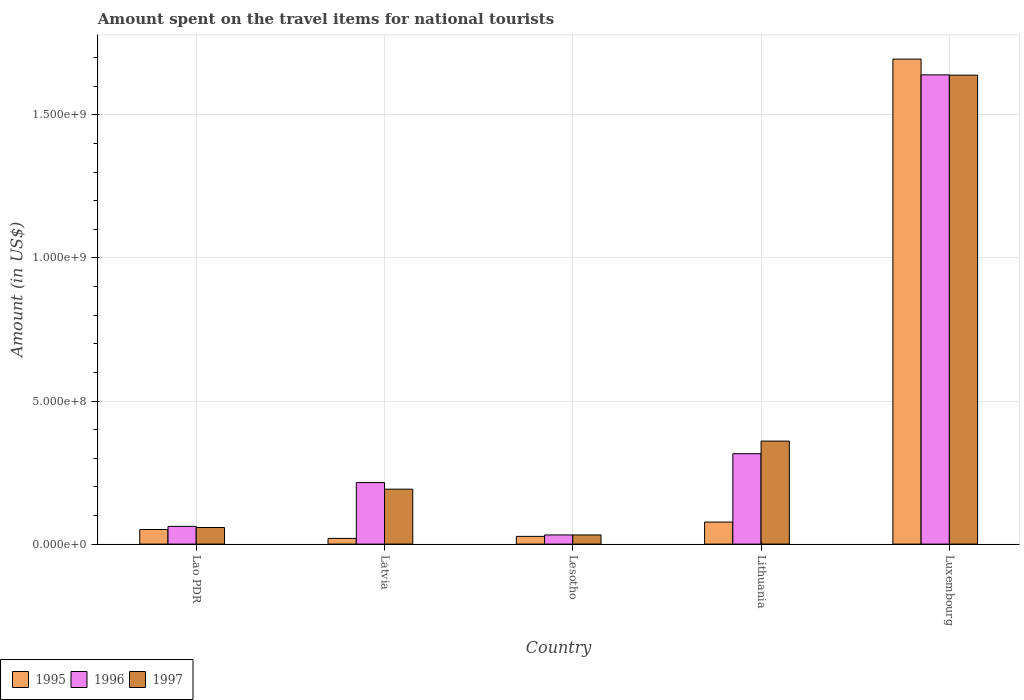Are the number of bars per tick equal to the number of legend labels?
Offer a terse response. Yes. Are the number of bars on each tick of the X-axis equal?
Make the answer very short. Yes. How many bars are there on the 1st tick from the left?
Your response must be concise. 3. How many bars are there on the 3rd tick from the right?
Make the answer very short. 3. What is the label of the 3rd group of bars from the left?
Give a very brief answer. Lesotho. In how many cases, is the number of bars for a given country not equal to the number of legend labels?
Offer a very short reply. 0. What is the amount spent on the travel items for national tourists in 1995 in Lao PDR?
Give a very brief answer. 5.10e+07. Across all countries, what is the maximum amount spent on the travel items for national tourists in 1996?
Give a very brief answer. 1.64e+09. Across all countries, what is the minimum amount spent on the travel items for national tourists in 1996?
Your response must be concise. 3.20e+07. In which country was the amount spent on the travel items for national tourists in 1996 maximum?
Offer a very short reply. Luxembourg. In which country was the amount spent on the travel items for national tourists in 1995 minimum?
Offer a very short reply. Latvia. What is the total amount spent on the travel items for national tourists in 1996 in the graph?
Offer a terse response. 2.26e+09. What is the difference between the amount spent on the travel items for national tourists in 1997 in Lao PDR and that in Lithuania?
Provide a succinct answer. -3.02e+08. What is the difference between the amount spent on the travel items for national tourists in 1995 in Luxembourg and the amount spent on the travel items for national tourists in 1997 in Lithuania?
Make the answer very short. 1.34e+09. What is the average amount spent on the travel items for national tourists in 1997 per country?
Your answer should be very brief. 4.56e+08. What is the difference between the amount spent on the travel items for national tourists of/in 1997 and amount spent on the travel items for national tourists of/in 1996 in Luxembourg?
Your answer should be very brief. -1.00e+06. In how many countries, is the amount spent on the travel items for national tourists in 1996 greater than 300000000 US$?
Provide a short and direct response. 2. What is the ratio of the amount spent on the travel items for national tourists in 1997 in Lesotho to that in Luxembourg?
Your answer should be compact. 0.02. Is the amount spent on the travel items for national tourists in 1996 in Latvia less than that in Luxembourg?
Give a very brief answer. Yes. Is the difference between the amount spent on the travel items for national tourists in 1997 in Lesotho and Lithuania greater than the difference between the amount spent on the travel items for national tourists in 1996 in Lesotho and Lithuania?
Give a very brief answer. No. What is the difference between the highest and the second highest amount spent on the travel items for national tourists in 1997?
Provide a succinct answer. 1.28e+09. What is the difference between the highest and the lowest amount spent on the travel items for national tourists in 1996?
Offer a very short reply. 1.61e+09. What does the 2nd bar from the left in Latvia represents?
Provide a short and direct response. 1996. What does the 3rd bar from the right in Latvia represents?
Your answer should be very brief. 1995. Is it the case that in every country, the sum of the amount spent on the travel items for national tourists in 1997 and amount spent on the travel items for national tourists in 1995 is greater than the amount spent on the travel items for national tourists in 1996?
Offer a very short reply. No. How many bars are there?
Offer a terse response. 15. Are all the bars in the graph horizontal?
Offer a terse response. No. What is the difference between two consecutive major ticks on the Y-axis?
Make the answer very short. 5.00e+08. Where does the legend appear in the graph?
Provide a succinct answer. Bottom left. How are the legend labels stacked?
Make the answer very short. Horizontal. What is the title of the graph?
Keep it short and to the point. Amount spent on the travel items for national tourists. What is the label or title of the Y-axis?
Keep it short and to the point. Amount (in US$). What is the Amount (in US$) of 1995 in Lao PDR?
Keep it short and to the point. 5.10e+07. What is the Amount (in US$) of 1996 in Lao PDR?
Your answer should be very brief. 6.20e+07. What is the Amount (in US$) of 1997 in Lao PDR?
Provide a short and direct response. 5.80e+07. What is the Amount (in US$) in 1996 in Latvia?
Your answer should be compact. 2.15e+08. What is the Amount (in US$) in 1997 in Latvia?
Offer a terse response. 1.92e+08. What is the Amount (in US$) of 1995 in Lesotho?
Keep it short and to the point. 2.70e+07. What is the Amount (in US$) of 1996 in Lesotho?
Give a very brief answer. 3.20e+07. What is the Amount (in US$) in 1997 in Lesotho?
Your answer should be compact. 3.20e+07. What is the Amount (in US$) of 1995 in Lithuania?
Offer a terse response. 7.70e+07. What is the Amount (in US$) of 1996 in Lithuania?
Make the answer very short. 3.16e+08. What is the Amount (in US$) in 1997 in Lithuania?
Your response must be concise. 3.60e+08. What is the Amount (in US$) of 1995 in Luxembourg?
Your answer should be compact. 1.70e+09. What is the Amount (in US$) in 1996 in Luxembourg?
Make the answer very short. 1.64e+09. What is the Amount (in US$) in 1997 in Luxembourg?
Your answer should be compact. 1.64e+09. Across all countries, what is the maximum Amount (in US$) in 1995?
Your response must be concise. 1.70e+09. Across all countries, what is the maximum Amount (in US$) in 1996?
Provide a succinct answer. 1.64e+09. Across all countries, what is the maximum Amount (in US$) in 1997?
Your answer should be compact. 1.64e+09. Across all countries, what is the minimum Amount (in US$) in 1995?
Your answer should be compact. 2.00e+07. Across all countries, what is the minimum Amount (in US$) of 1996?
Offer a terse response. 3.20e+07. Across all countries, what is the minimum Amount (in US$) of 1997?
Your answer should be compact. 3.20e+07. What is the total Amount (in US$) of 1995 in the graph?
Make the answer very short. 1.87e+09. What is the total Amount (in US$) of 1996 in the graph?
Your answer should be compact. 2.26e+09. What is the total Amount (in US$) of 1997 in the graph?
Provide a short and direct response. 2.28e+09. What is the difference between the Amount (in US$) of 1995 in Lao PDR and that in Latvia?
Provide a succinct answer. 3.10e+07. What is the difference between the Amount (in US$) of 1996 in Lao PDR and that in Latvia?
Offer a very short reply. -1.53e+08. What is the difference between the Amount (in US$) of 1997 in Lao PDR and that in Latvia?
Keep it short and to the point. -1.34e+08. What is the difference between the Amount (in US$) in 1995 in Lao PDR and that in Lesotho?
Provide a short and direct response. 2.40e+07. What is the difference between the Amount (in US$) in 1996 in Lao PDR and that in Lesotho?
Ensure brevity in your answer.  3.00e+07. What is the difference between the Amount (in US$) in 1997 in Lao PDR and that in Lesotho?
Give a very brief answer. 2.60e+07. What is the difference between the Amount (in US$) in 1995 in Lao PDR and that in Lithuania?
Give a very brief answer. -2.60e+07. What is the difference between the Amount (in US$) of 1996 in Lao PDR and that in Lithuania?
Offer a terse response. -2.54e+08. What is the difference between the Amount (in US$) of 1997 in Lao PDR and that in Lithuania?
Your response must be concise. -3.02e+08. What is the difference between the Amount (in US$) in 1995 in Lao PDR and that in Luxembourg?
Provide a succinct answer. -1.64e+09. What is the difference between the Amount (in US$) in 1996 in Lao PDR and that in Luxembourg?
Give a very brief answer. -1.58e+09. What is the difference between the Amount (in US$) of 1997 in Lao PDR and that in Luxembourg?
Offer a very short reply. -1.58e+09. What is the difference between the Amount (in US$) of 1995 in Latvia and that in Lesotho?
Provide a succinct answer. -7.00e+06. What is the difference between the Amount (in US$) of 1996 in Latvia and that in Lesotho?
Provide a short and direct response. 1.83e+08. What is the difference between the Amount (in US$) of 1997 in Latvia and that in Lesotho?
Offer a very short reply. 1.60e+08. What is the difference between the Amount (in US$) of 1995 in Latvia and that in Lithuania?
Offer a terse response. -5.70e+07. What is the difference between the Amount (in US$) of 1996 in Latvia and that in Lithuania?
Provide a succinct answer. -1.01e+08. What is the difference between the Amount (in US$) of 1997 in Latvia and that in Lithuania?
Your answer should be compact. -1.68e+08. What is the difference between the Amount (in US$) of 1995 in Latvia and that in Luxembourg?
Give a very brief answer. -1.68e+09. What is the difference between the Amount (in US$) of 1996 in Latvia and that in Luxembourg?
Your answer should be compact. -1.42e+09. What is the difference between the Amount (in US$) of 1997 in Latvia and that in Luxembourg?
Provide a succinct answer. -1.45e+09. What is the difference between the Amount (in US$) of 1995 in Lesotho and that in Lithuania?
Provide a succinct answer. -5.00e+07. What is the difference between the Amount (in US$) in 1996 in Lesotho and that in Lithuania?
Ensure brevity in your answer.  -2.84e+08. What is the difference between the Amount (in US$) of 1997 in Lesotho and that in Lithuania?
Your answer should be very brief. -3.28e+08. What is the difference between the Amount (in US$) of 1995 in Lesotho and that in Luxembourg?
Ensure brevity in your answer.  -1.67e+09. What is the difference between the Amount (in US$) in 1996 in Lesotho and that in Luxembourg?
Make the answer very short. -1.61e+09. What is the difference between the Amount (in US$) in 1997 in Lesotho and that in Luxembourg?
Offer a terse response. -1.61e+09. What is the difference between the Amount (in US$) of 1995 in Lithuania and that in Luxembourg?
Give a very brief answer. -1.62e+09. What is the difference between the Amount (in US$) of 1996 in Lithuania and that in Luxembourg?
Keep it short and to the point. -1.32e+09. What is the difference between the Amount (in US$) of 1997 in Lithuania and that in Luxembourg?
Offer a very short reply. -1.28e+09. What is the difference between the Amount (in US$) in 1995 in Lao PDR and the Amount (in US$) in 1996 in Latvia?
Provide a short and direct response. -1.64e+08. What is the difference between the Amount (in US$) in 1995 in Lao PDR and the Amount (in US$) in 1997 in Latvia?
Provide a succinct answer. -1.41e+08. What is the difference between the Amount (in US$) in 1996 in Lao PDR and the Amount (in US$) in 1997 in Latvia?
Make the answer very short. -1.30e+08. What is the difference between the Amount (in US$) in 1995 in Lao PDR and the Amount (in US$) in 1996 in Lesotho?
Offer a terse response. 1.90e+07. What is the difference between the Amount (in US$) of 1995 in Lao PDR and the Amount (in US$) of 1997 in Lesotho?
Your answer should be very brief. 1.90e+07. What is the difference between the Amount (in US$) of 1996 in Lao PDR and the Amount (in US$) of 1997 in Lesotho?
Provide a short and direct response. 3.00e+07. What is the difference between the Amount (in US$) in 1995 in Lao PDR and the Amount (in US$) in 1996 in Lithuania?
Offer a very short reply. -2.65e+08. What is the difference between the Amount (in US$) of 1995 in Lao PDR and the Amount (in US$) of 1997 in Lithuania?
Ensure brevity in your answer.  -3.09e+08. What is the difference between the Amount (in US$) of 1996 in Lao PDR and the Amount (in US$) of 1997 in Lithuania?
Keep it short and to the point. -2.98e+08. What is the difference between the Amount (in US$) of 1995 in Lao PDR and the Amount (in US$) of 1996 in Luxembourg?
Provide a succinct answer. -1.59e+09. What is the difference between the Amount (in US$) of 1995 in Lao PDR and the Amount (in US$) of 1997 in Luxembourg?
Your answer should be compact. -1.59e+09. What is the difference between the Amount (in US$) in 1996 in Lao PDR and the Amount (in US$) in 1997 in Luxembourg?
Your response must be concise. -1.58e+09. What is the difference between the Amount (in US$) of 1995 in Latvia and the Amount (in US$) of 1996 in Lesotho?
Make the answer very short. -1.20e+07. What is the difference between the Amount (in US$) of 1995 in Latvia and the Amount (in US$) of 1997 in Lesotho?
Your answer should be very brief. -1.20e+07. What is the difference between the Amount (in US$) of 1996 in Latvia and the Amount (in US$) of 1997 in Lesotho?
Your answer should be very brief. 1.83e+08. What is the difference between the Amount (in US$) of 1995 in Latvia and the Amount (in US$) of 1996 in Lithuania?
Your answer should be compact. -2.96e+08. What is the difference between the Amount (in US$) in 1995 in Latvia and the Amount (in US$) in 1997 in Lithuania?
Provide a succinct answer. -3.40e+08. What is the difference between the Amount (in US$) of 1996 in Latvia and the Amount (in US$) of 1997 in Lithuania?
Your answer should be compact. -1.45e+08. What is the difference between the Amount (in US$) in 1995 in Latvia and the Amount (in US$) in 1996 in Luxembourg?
Your answer should be very brief. -1.62e+09. What is the difference between the Amount (in US$) of 1995 in Latvia and the Amount (in US$) of 1997 in Luxembourg?
Keep it short and to the point. -1.62e+09. What is the difference between the Amount (in US$) in 1996 in Latvia and the Amount (in US$) in 1997 in Luxembourg?
Offer a very short reply. -1.42e+09. What is the difference between the Amount (in US$) in 1995 in Lesotho and the Amount (in US$) in 1996 in Lithuania?
Offer a terse response. -2.89e+08. What is the difference between the Amount (in US$) in 1995 in Lesotho and the Amount (in US$) in 1997 in Lithuania?
Keep it short and to the point. -3.33e+08. What is the difference between the Amount (in US$) of 1996 in Lesotho and the Amount (in US$) of 1997 in Lithuania?
Your answer should be compact. -3.28e+08. What is the difference between the Amount (in US$) in 1995 in Lesotho and the Amount (in US$) in 1996 in Luxembourg?
Your response must be concise. -1.61e+09. What is the difference between the Amount (in US$) of 1995 in Lesotho and the Amount (in US$) of 1997 in Luxembourg?
Offer a very short reply. -1.61e+09. What is the difference between the Amount (in US$) in 1996 in Lesotho and the Amount (in US$) in 1997 in Luxembourg?
Provide a short and direct response. -1.61e+09. What is the difference between the Amount (in US$) of 1995 in Lithuania and the Amount (in US$) of 1996 in Luxembourg?
Give a very brief answer. -1.56e+09. What is the difference between the Amount (in US$) of 1995 in Lithuania and the Amount (in US$) of 1997 in Luxembourg?
Your answer should be compact. -1.56e+09. What is the difference between the Amount (in US$) of 1996 in Lithuania and the Amount (in US$) of 1997 in Luxembourg?
Give a very brief answer. -1.32e+09. What is the average Amount (in US$) in 1995 per country?
Your answer should be compact. 3.74e+08. What is the average Amount (in US$) in 1996 per country?
Keep it short and to the point. 4.53e+08. What is the average Amount (in US$) of 1997 per country?
Make the answer very short. 4.56e+08. What is the difference between the Amount (in US$) of 1995 and Amount (in US$) of 1996 in Lao PDR?
Your response must be concise. -1.10e+07. What is the difference between the Amount (in US$) in 1995 and Amount (in US$) in 1997 in Lao PDR?
Provide a succinct answer. -7.00e+06. What is the difference between the Amount (in US$) of 1996 and Amount (in US$) of 1997 in Lao PDR?
Give a very brief answer. 4.00e+06. What is the difference between the Amount (in US$) of 1995 and Amount (in US$) of 1996 in Latvia?
Make the answer very short. -1.95e+08. What is the difference between the Amount (in US$) in 1995 and Amount (in US$) in 1997 in Latvia?
Provide a succinct answer. -1.72e+08. What is the difference between the Amount (in US$) in 1996 and Amount (in US$) in 1997 in Latvia?
Provide a succinct answer. 2.30e+07. What is the difference between the Amount (in US$) of 1995 and Amount (in US$) of 1996 in Lesotho?
Your answer should be very brief. -5.00e+06. What is the difference between the Amount (in US$) of 1995 and Amount (in US$) of 1997 in Lesotho?
Your response must be concise. -5.00e+06. What is the difference between the Amount (in US$) of 1995 and Amount (in US$) of 1996 in Lithuania?
Give a very brief answer. -2.39e+08. What is the difference between the Amount (in US$) in 1995 and Amount (in US$) in 1997 in Lithuania?
Give a very brief answer. -2.83e+08. What is the difference between the Amount (in US$) of 1996 and Amount (in US$) of 1997 in Lithuania?
Provide a succinct answer. -4.40e+07. What is the difference between the Amount (in US$) in 1995 and Amount (in US$) in 1996 in Luxembourg?
Your answer should be compact. 5.50e+07. What is the difference between the Amount (in US$) in 1995 and Amount (in US$) in 1997 in Luxembourg?
Provide a succinct answer. 5.60e+07. What is the ratio of the Amount (in US$) of 1995 in Lao PDR to that in Latvia?
Provide a succinct answer. 2.55. What is the ratio of the Amount (in US$) of 1996 in Lao PDR to that in Latvia?
Give a very brief answer. 0.29. What is the ratio of the Amount (in US$) of 1997 in Lao PDR to that in Latvia?
Give a very brief answer. 0.3. What is the ratio of the Amount (in US$) of 1995 in Lao PDR to that in Lesotho?
Give a very brief answer. 1.89. What is the ratio of the Amount (in US$) of 1996 in Lao PDR to that in Lesotho?
Provide a short and direct response. 1.94. What is the ratio of the Amount (in US$) of 1997 in Lao PDR to that in Lesotho?
Keep it short and to the point. 1.81. What is the ratio of the Amount (in US$) of 1995 in Lao PDR to that in Lithuania?
Ensure brevity in your answer.  0.66. What is the ratio of the Amount (in US$) in 1996 in Lao PDR to that in Lithuania?
Offer a terse response. 0.2. What is the ratio of the Amount (in US$) of 1997 in Lao PDR to that in Lithuania?
Provide a succinct answer. 0.16. What is the ratio of the Amount (in US$) of 1995 in Lao PDR to that in Luxembourg?
Provide a short and direct response. 0.03. What is the ratio of the Amount (in US$) of 1996 in Lao PDR to that in Luxembourg?
Offer a terse response. 0.04. What is the ratio of the Amount (in US$) of 1997 in Lao PDR to that in Luxembourg?
Offer a very short reply. 0.04. What is the ratio of the Amount (in US$) in 1995 in Latvia to that in Lesotho?
Offer a terse response. 0.74. What is the ratio of the Amount (in US$) of 1996 in Latvia to that in Lesotho?
Ensure brevity in your answer.  6.72. What is the ratio of the Amount (in US$) in 1995 in Latvia to that in Lithuania?
Offer a terse response. 0.26. What is the ratio of the Amount (in US$) of 1996 in Latvia to that in Lithuania?
Offer a terse response. 0.68. What is the ratio of the Amount (in US$) of 1997 in Latvia to that in Lithuania?
Offer a very short reply. 0.53. What is the ratio of the Amount (in US$) of 1995 in Latvia to that in Luxembourg?
Ensure brevity in your answer.  0.01. What is the ratio of the Amount (in US$) in 1996 in Latvia to that in Luxembourg?
Keep it short and to the point. 0.13. What is the ratio of the Amount (in US$) in 1997 in Latvia to that in Luxembourg?
Your response must be concise. 0.12. What is the ratio of the Amount (in US$) in 1995 in Lesotho to that in Lithuania?
Ensure brevity in your answer.  0.35. What is the ratio of the Amount (in US$) of 1996 in Lesotho to that in Lithuania?
Give a very brief answer. 0.1. What is the ratio of the Amount (in US$) in 1997 in Lesotho to that in Lithuania?
Offer a very short reply. 0.09. What is the ratio of the Amount (in US$) of 1995 in Lesotho to that in Luxembourg?
Your answer should be compact. 0.02. What is the ratio of the Amount (in US$) in 1996 in Lesotho to that in Luxembourg?
Give a very brief answer. 0.02. What is the ratio of the Amount (in US$) in 1997 in Lesotho to that in Luxembourg?
Provide a succinct answer. 0.02. What is the ratio of the Amount (in US$) of 1995 in Lithuania to that in Luxembourg?
Your answer should be very brief. 0.05. What is the ratio of the Amount (in US$) in 1996 in Lithuania to that in Luxembourg?
Provide a succinct answer. 0.19. What is the ratio of the Amount (in US$) of 1997 in Lithuania to that in Luxembourg?
Offer a terse response. 0.22. What is the difference between the highest and the second highest Amount (in US$) of 1995?
Give a very brief answer. 1.62e+09. What is the difference between the highest and the second highest Amount (in US$) in 1996?
Give a very brief answer. 1.32e+09. What is the difference between the highest and the second highest Amount (in US$) in 1997?
Keep it short and to the point. 1.28e+09. What is the difference between the highest and the lowest Amount (in US$) in 1995?
Your answer should be very brief. 1.68e+09. What is the difference between the highest and the lowest Amount (in US$) of 1996?
Provide a short and direct response. 1.61e+09. What is the difference between the highest and the lowest Amount (in US$) in 1997?
Your response must be concise. 1.61e+09. 